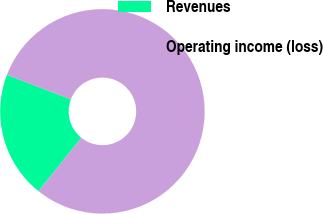<chart> <loc_0><loc_0><loc_500><loc_500><pie_chart><fcel>Revenues<fcel>Operating income (loss)<nl><fcel>20.06%<fcel>79.94%<nl></chart> 